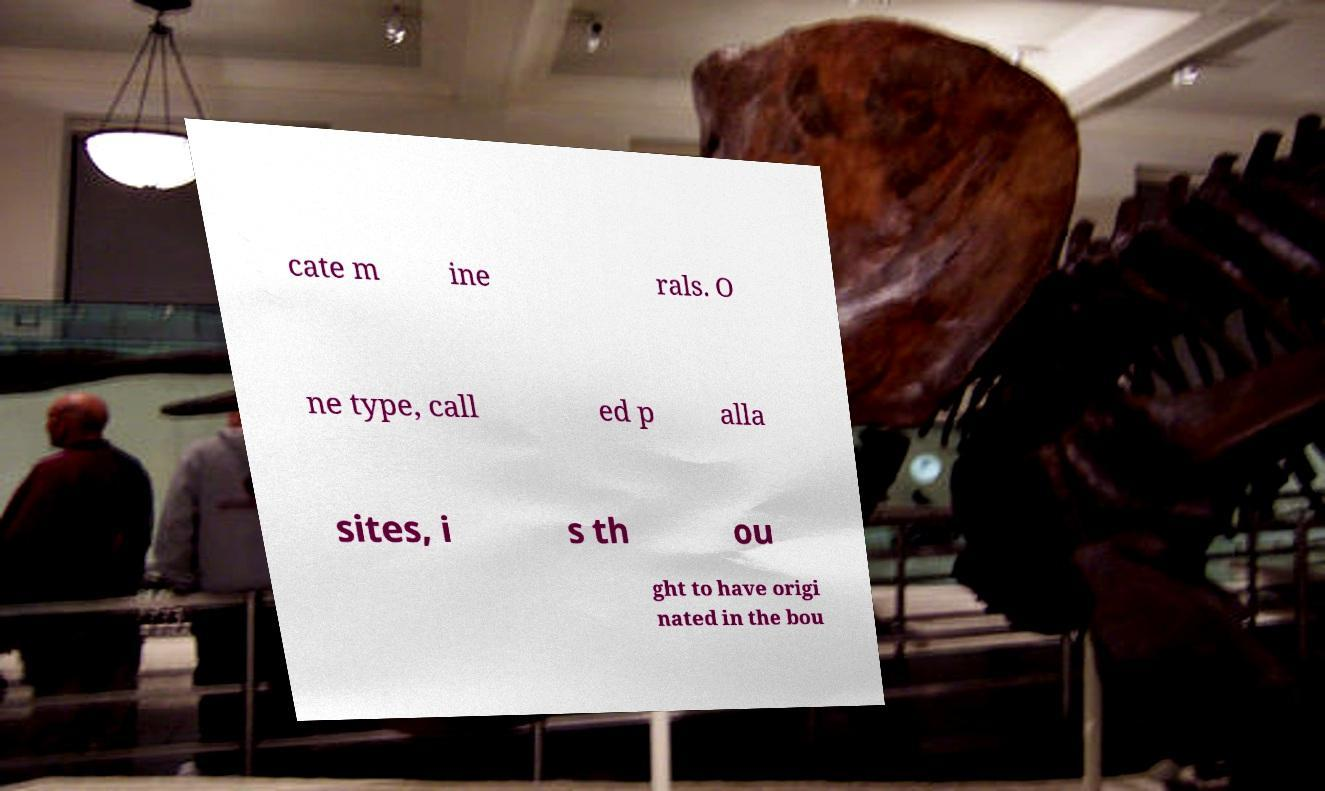I need the written content from this picture converted into text. Can you do that? cate m ine rals. O ne type, call ed p alla sites, i s th ou ght to have origi nated in the bou 